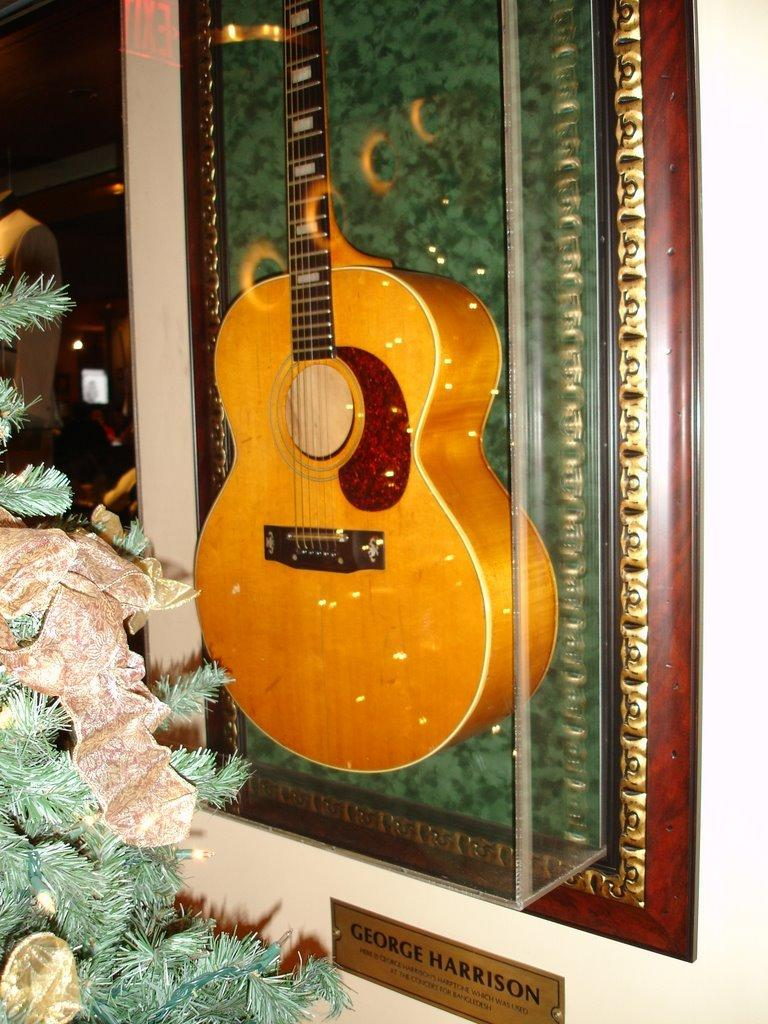What musical instrument can be seen in the background of the image? There is a guitar in the background of the image. What living organism is present in the image? There is a plant in the image. How many eyes can be seen on the guitar in the image? There are no eyes on the guitar in the image, as it is an inanimate object. What type of tooth is being used to play the guitar in the image? There is no tooth being used to play the guitar in the image, as it is not a living organism. 